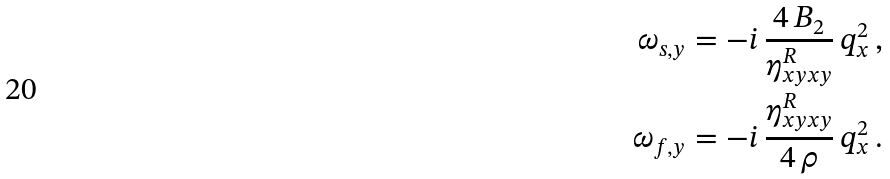<formula> <loc_0><loc_0><loc_500><loc_500>\omega _ { s , y } & = - i \, \frac { 4 \, B _ { 2 } } { \eta _ { x y x y } ^ { R } } \, q _ { x } ^ { 2 } \, , \\ \omega _ { f , y } & = - i \, \frac { \eta _ { x y x y } ^ { R } } { 4 \, \rho } \, q _ { x } ^ { 2 } \, .</formula> 